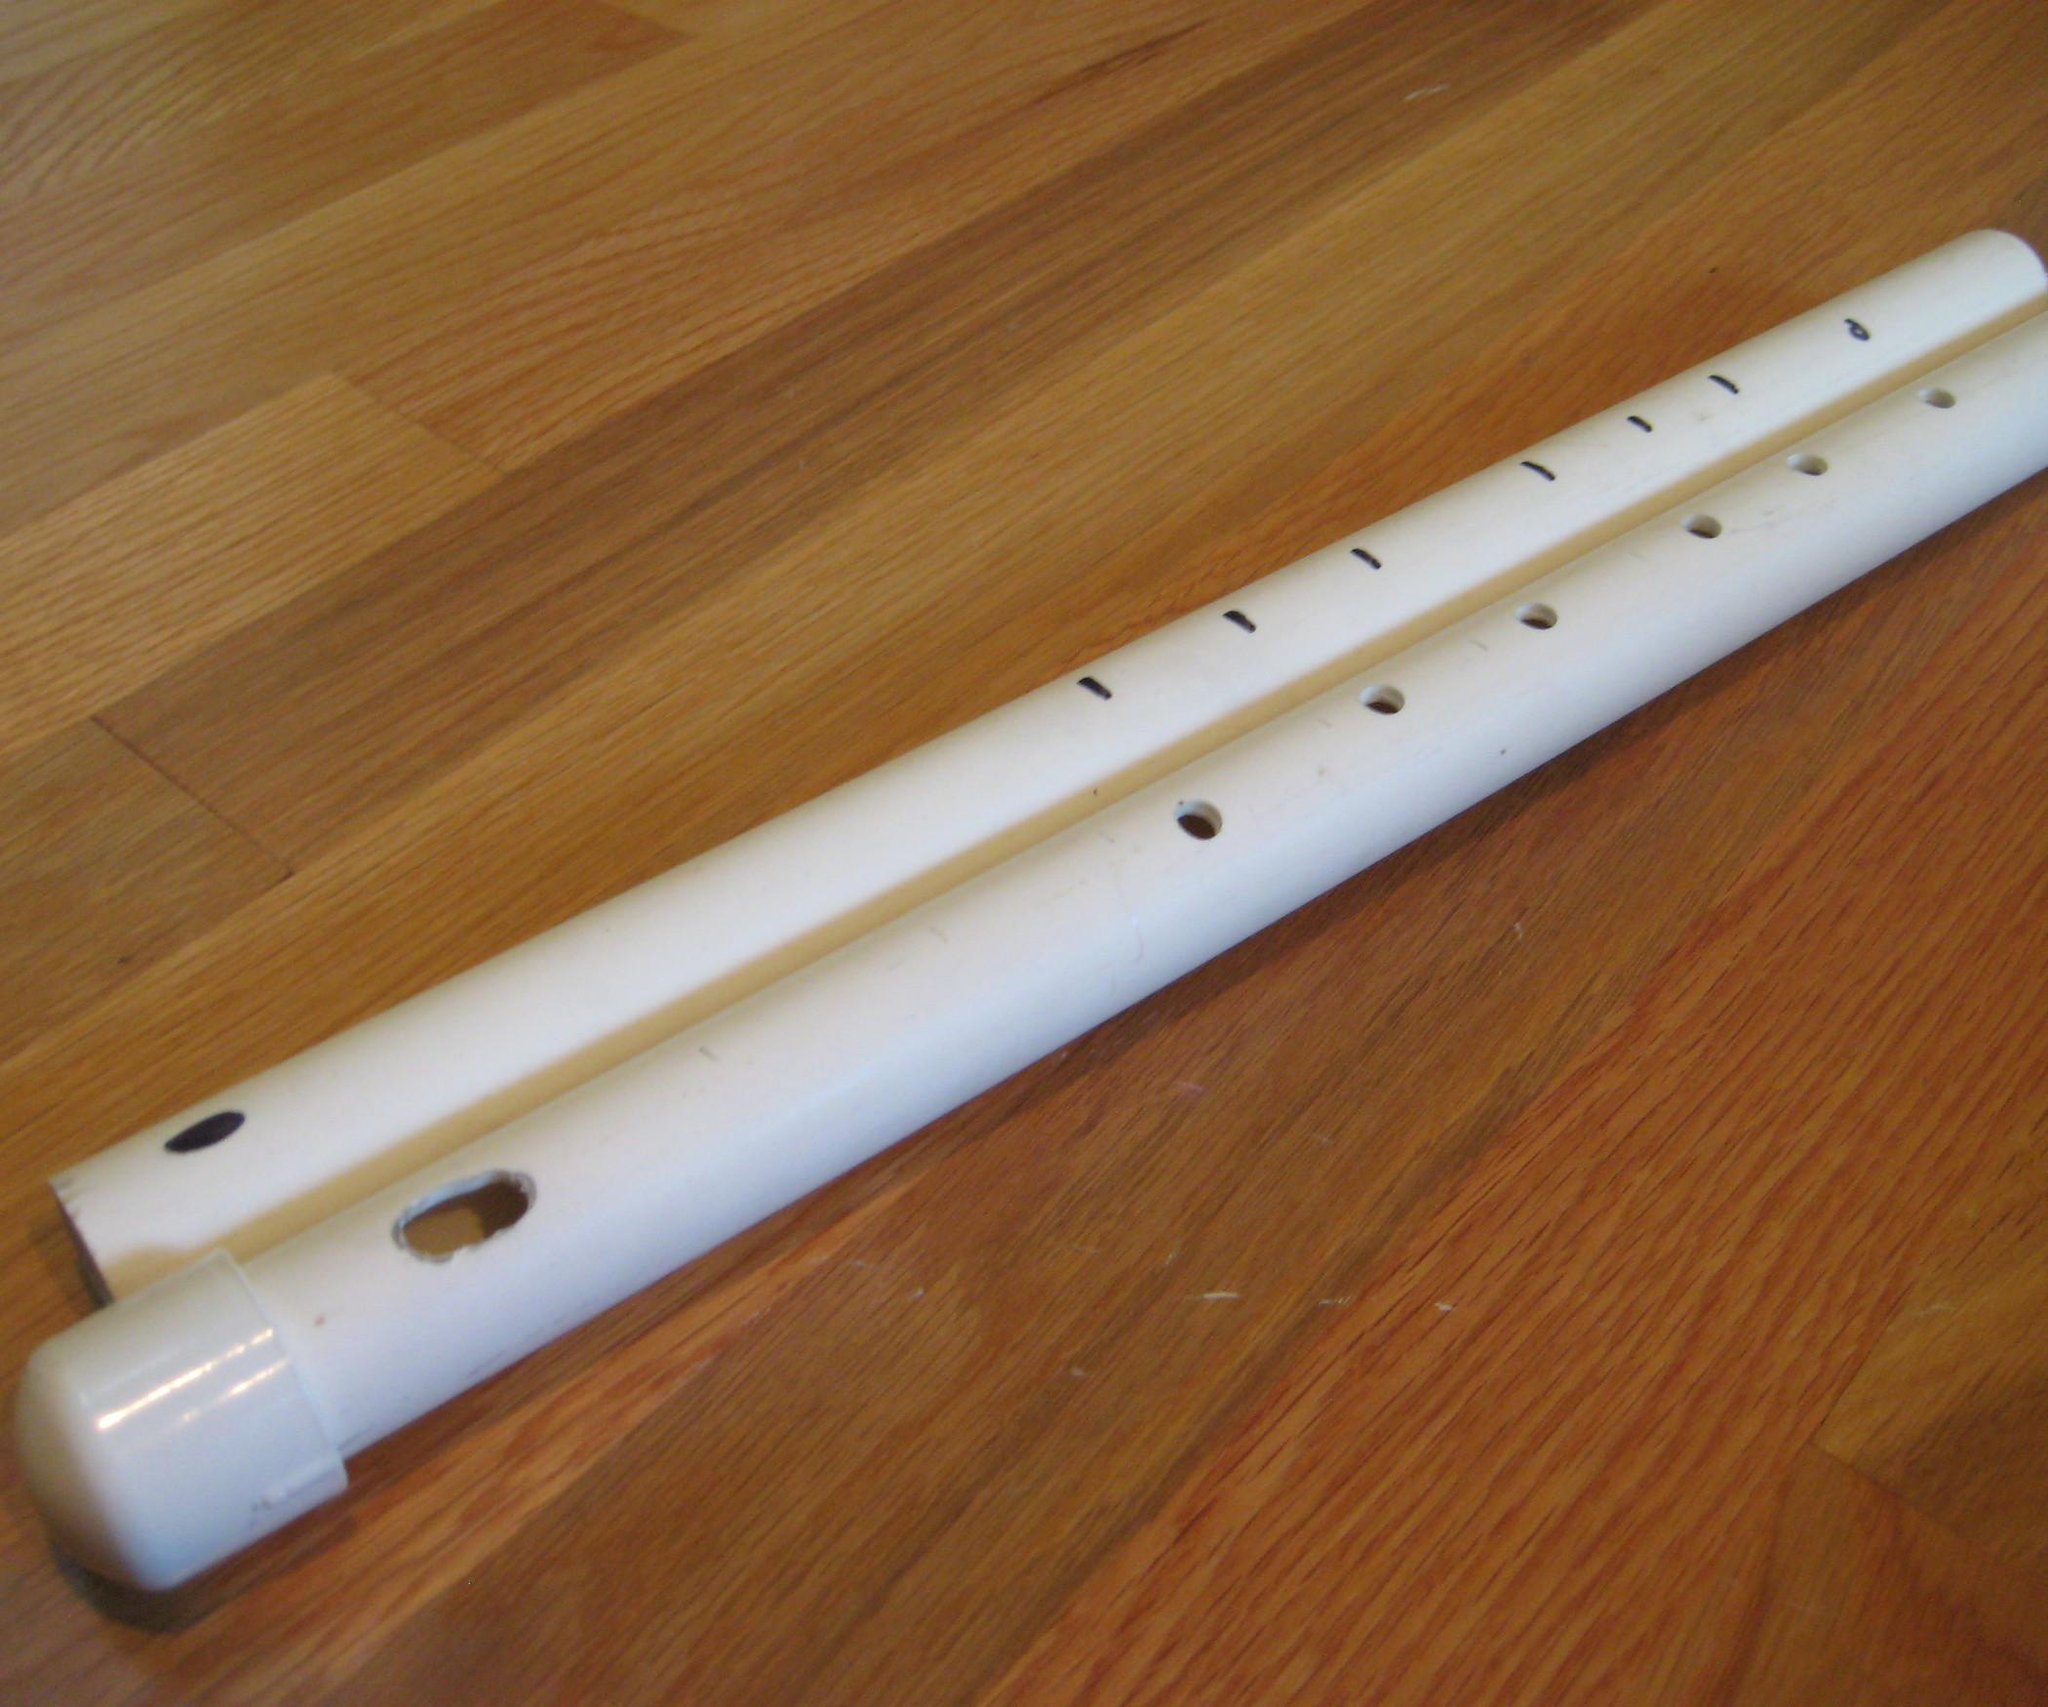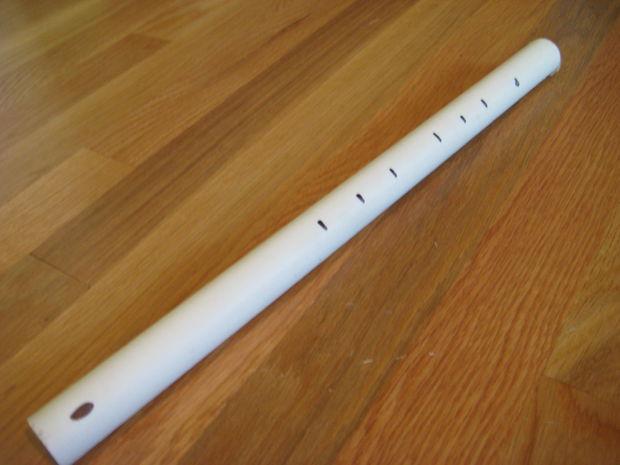The first image is the image on the left, the second image is the image on the right. Analyze the images presented: Is the assertion "The left image shows a white PVC-look tube with a cut part and a metal-bladed tool near it." valid? Answer yes or no. No. The first image is the image on the left, the second image is the image on the right. For the images displayed, is the sentence "A sharp object sits near a pipe in the image on the left." factually correct? Answer yes or no. No. 